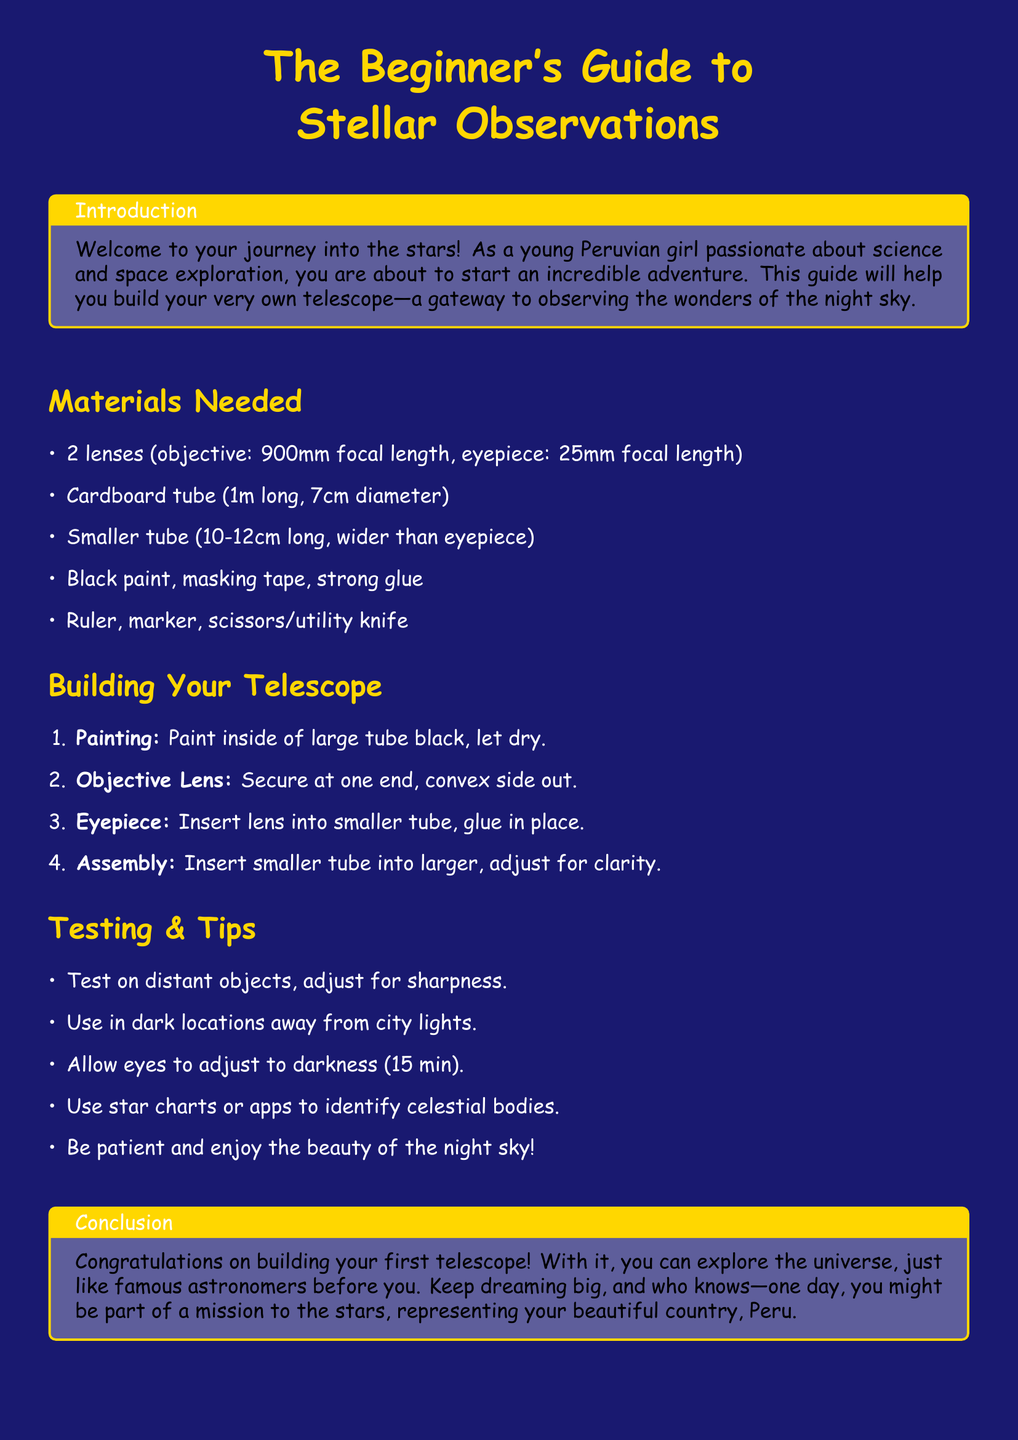What is the focal length of the objective lens? The focal length of the objective lens is specified in the materials needed section.
Answer: 900mm What color should the inside of the large tube be painted? The document mentions painting the inside of the large tube before assembly.
Answer: Black How long should the smaller tube be? The document states the length of the smaller tube in the materials needed section.
Answer: 10-12cm What should you use to adjust the telescope for clarity? This information is found in the building instructions and involves the smaller tube.
Answer: Adjust What are you recommended to use for identifying celestial bodies? The testing and tips section provides suggestions for identifying celestial objects.
Answer: Star charts or apps What is the recommended time for your eyes to adjust to darkness? The document suggests a specific duration for this adjustment.
Answer: 15 min What is the final message in the conclusion about dreams? The conclusion amplifies an inspiring thought regarding aspirations related to astronomy.
Answer: Dream big What type of document is this? The overall title and content indicate the nature of this document.
Answer: User guide 